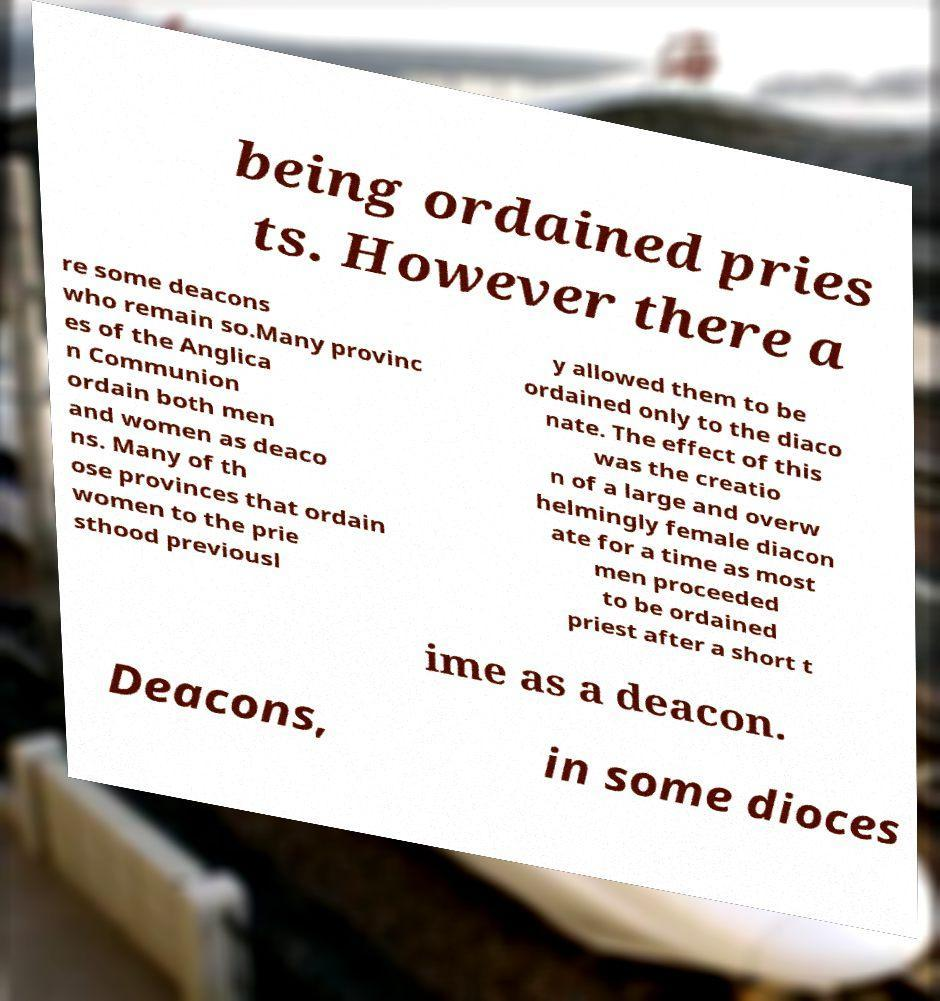I need the written content from this picture converted into text. Can you do that? being ordained pries ts. However there a re some deacons who remain so.Many provinc es of the Anglica n Communion ordain both men and women as deaco ns. Many of th ose provinces that ordain women to the prie sthood previousl y allowed them to be ordained only to the diaco nate. The effect of this was the creatio n of a large and overw helmingly female diacon ate for a time as most men proceeded to be ordained priest after a short t ime as a deacon. Deacons, in some dioces 